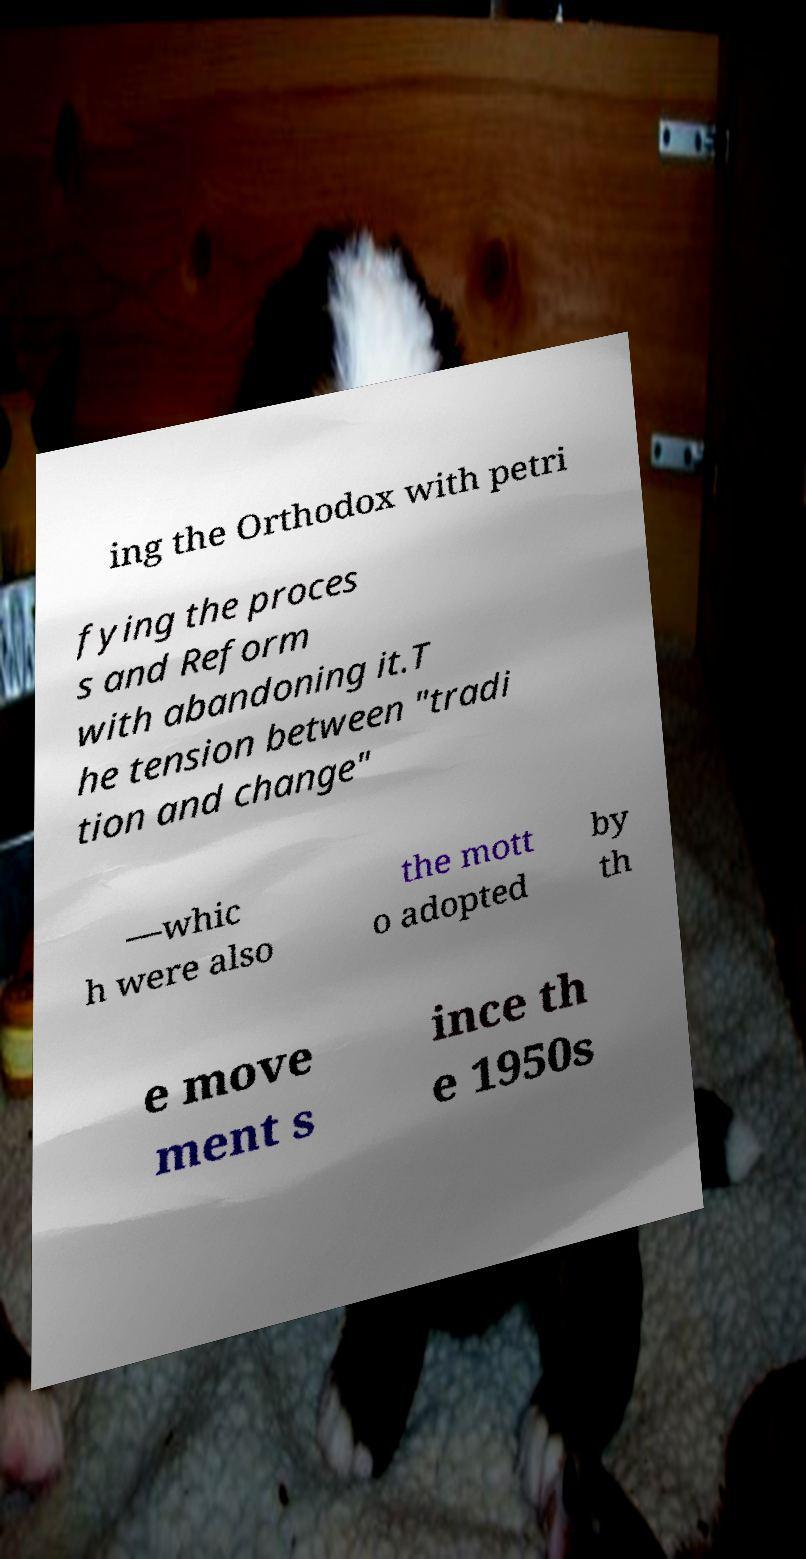What messages or text are displayed in this image? I need them in a readable, typed format. ing the Orthodox with petri fying the proces s and Reform with abandoning it.T he tension between "tradi tion and change" —whic h were also the mott o adopted by th e move ment s ince th e 1950s 